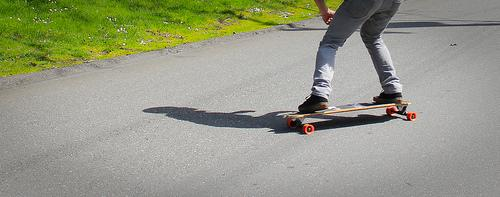What is the correlation between the skateboard's wheels and the grass? The wheels on the skateboard contrast with the grass as they are orange while the grass is bright green. What color are the skateboarder's shoes? The skateboarder is wearing black shoes. Describe the clothing of the person using the skateboard. The person is wearing gray jeans and black sneakers. In a referential expression grounding task, how would you describe the skateboarder's position on the board? The skateboarder has both feet on the skateboard with knees bent and turned inwards. Describe the environment surrounding the skateboarder. It's a sunny outdoor daytime scene with the skateboarder on a smooth gray concrete roadway, beside a green grassy patch. Identify the features of the skateboard in the image. The skateboard is black with four small orange wheels. Mention a detail about the lighting in the image. The sunlight is creating shadows on the ground from the person and the skateboard. Is the skateboarder wearing any protective gear? The skateboarder doesn't appear to be wearing any protective gear. Choose an advertisement tagline for a skateboarding product based on the image. "Unleash your inner skater: Ride with confidence on our vibrant orange-wheeled skateboard!" What is the primary action happening in the image? A person is skateboarding on the street. 